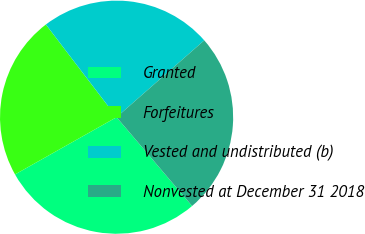<chart> <loc_0><loc_0><loc_500><loc_500><pie_chart><fcel>Granted<fcel>Forfeitures<fcel>Vested and undistributed (b)<fcel>Nonvested at December 31 2018<nl><fcel>28.05%<fcel>22.8%<fcel>23.92%<fcel>25.24%<nl></chart> 